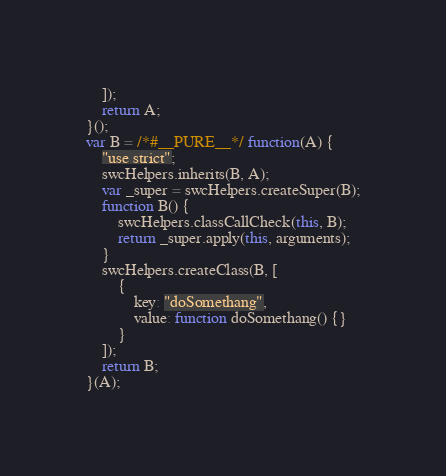<code> <loc_0><loc_0><loc_500><loc_500><_JavaScript_>    ]);
    return A;
}();
var B = /*#__PURE__*/ function(A) {
    "use strict";
    swcHelpers.inherits(B, A);
    var _super = swcHelpers.createSuper(B);
    function B() {
        swcHelpers.classCallCheck(this, B);
        return _super.apply(this, arguments);
    }
    swcHelpers.createClass(B, [
        {
            key: "doSomethang",
            value: function doSomethang() {}
        }
    ]);
    return B;
}(A);
</code> 